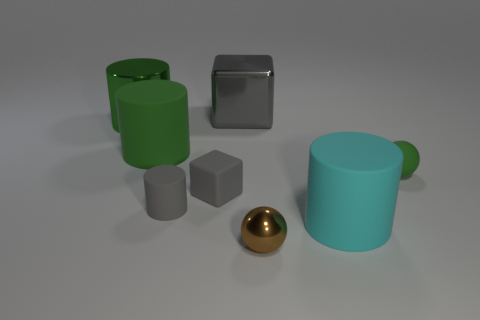There is another cube that is the same color as the big cube; what is its size?
Your answer should be very brief. Small. Are there any small objects in front of the ball that is on the right side of the cyan matte cylinder?
Give a very brief answer. Yes. What is the thing behind the large metal cylinder made of?
Provide a succinct answer. Metal. Is the large cylinder that is on the right side of the green matte cylinder made of the same material as the gray object right of the matte cube?
Offer a terse response. No. Are there the same number of matte cubes that are behind the green sphere and gray objects that are in front of the small brown metallic sphere?
Give a very brief answer. Yes. What number of green cylinders are the same material as the big cube?
Your answer should be compact. 1. What shape is the matte object that is the same color as the tiny cylinder?
Keep it short and to the point. Cube. What is the size of the cube behind the big green cylinder that is on the right side of the large green metal thing?
Your answer should be compact. Large. Is the shape of the metal thing in front of the small green rubber sphere the same as the green matte thing to the left of the big gray object?
Your answer should be compact. No. Is the number of green things that are to the left of the small shiny object the same as the number of small matte spheres?
Offer a terse response. No. 